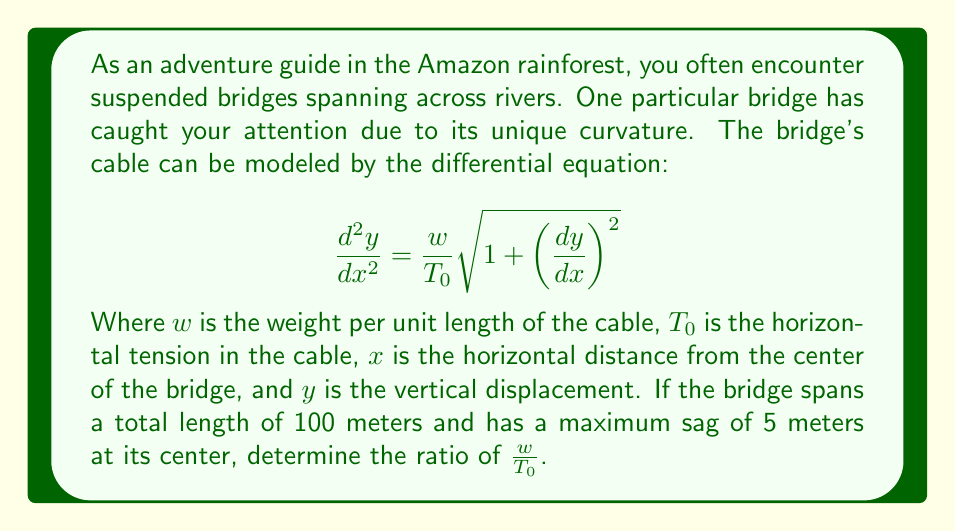Can you answer this question? To solve this problem, we'll follow these steps:

1) For a symmetric bridge, we can assume that the lowest point (maximum sag) occurs at the center, where $x = 0$ and $y = -5$ (assuming positive y is upward).

2) At this point, due to symmetry, $\frac{dy}{dx} = 0$.

3) The general solution to the given differential equation is:

   $$y = \frac{T_0}{w}\cosh\left(\frac{wx}{T_0} + C_1\right) + C_2$$

4) Using the conditions at the center point:

   At $x = 0$, $y = -5$:
   $$-5 = \frac{T_0}{w}\cosh(C_1) + C_2$$

   And since $\frac{dy}{dx} = 0$ at $x = 0$:
   $$0 = \sinh(C_1)$$
   
   This implies $C_1 = 0$

5) Substituting back:
   $$-5 = \frac{T_0}{w} + C_2$$
   $$C_2 = -5 - \frac{T_0}{w}$$

6) Now, at the end of the bridge, $x = 50$ (half the total length) and $y = 0$:

   $$0 = \frac{T_0}{w}\cosh\left(\frac{50w}{T_0}\right) + \left(-5 - \frac{T_0}{w}\right)$$

7) Rearranging:

   $$\frac{T_0}{w} + 5 = \frac{T_0}{w}\cosh\left(\frac{50w}{T_0}\right)$$

8) Let $\frac{T_0}{w} = k$. Then:

   $$k + 5 = k\cosh\left(\frac{50}{k}\right)$$

9) This equation can be solved numerically. Using a numerical method or graphing calculator, we find:

   $$k \approx 250.54$$

10) Therefore:

    $$\frac{w}{T_0} = \frac{1}{k} \approx 0.00399$$
Answer: The ratio of $\frac{w}{T_0}$ is approximately 0.00399. 